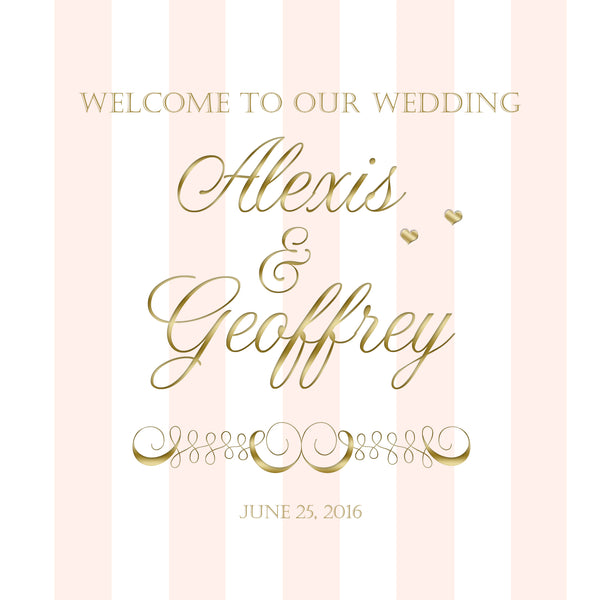What could be the general atmosphere for an evening reception based on this invitation design? An evening reception based on the pink and gold invitation design would have a warm, romantic, and elegant atmosphere. The venue would be illuminated with soft, ambient lighting, possibly including candles and chandeliers that cast a golden glow. The tables would be adorned with luxurious pink and gold decor, creating an intimate and opulent setting. Soft music might play in the background as guests enjoy a chic cocktail hour, followed by a gourmet dinner. The evening would culminate in a festive celebration with dancing and toasts under the starlit sky or in a beautifully lit indoor space. 